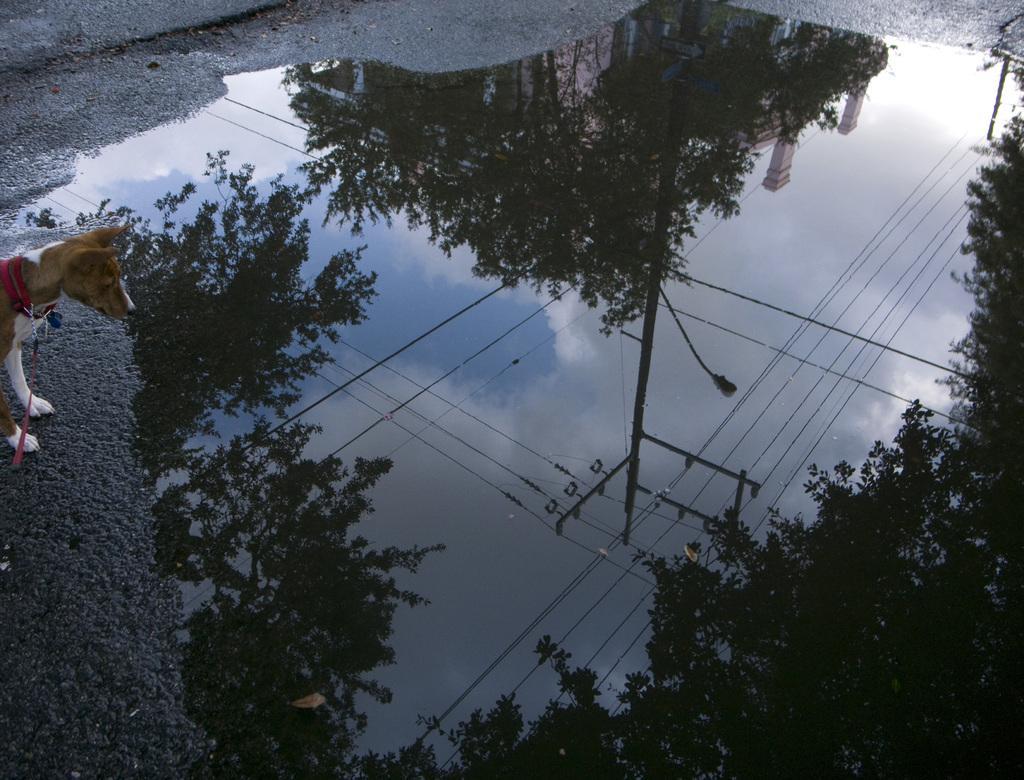How would you summarize this image in a sentence or two? In this image we can see water on a surface. On the left side there is a dog with collar and belt. On the water we can see reflections of trees, also there is an electric pole with wires and we can see part of a building. 